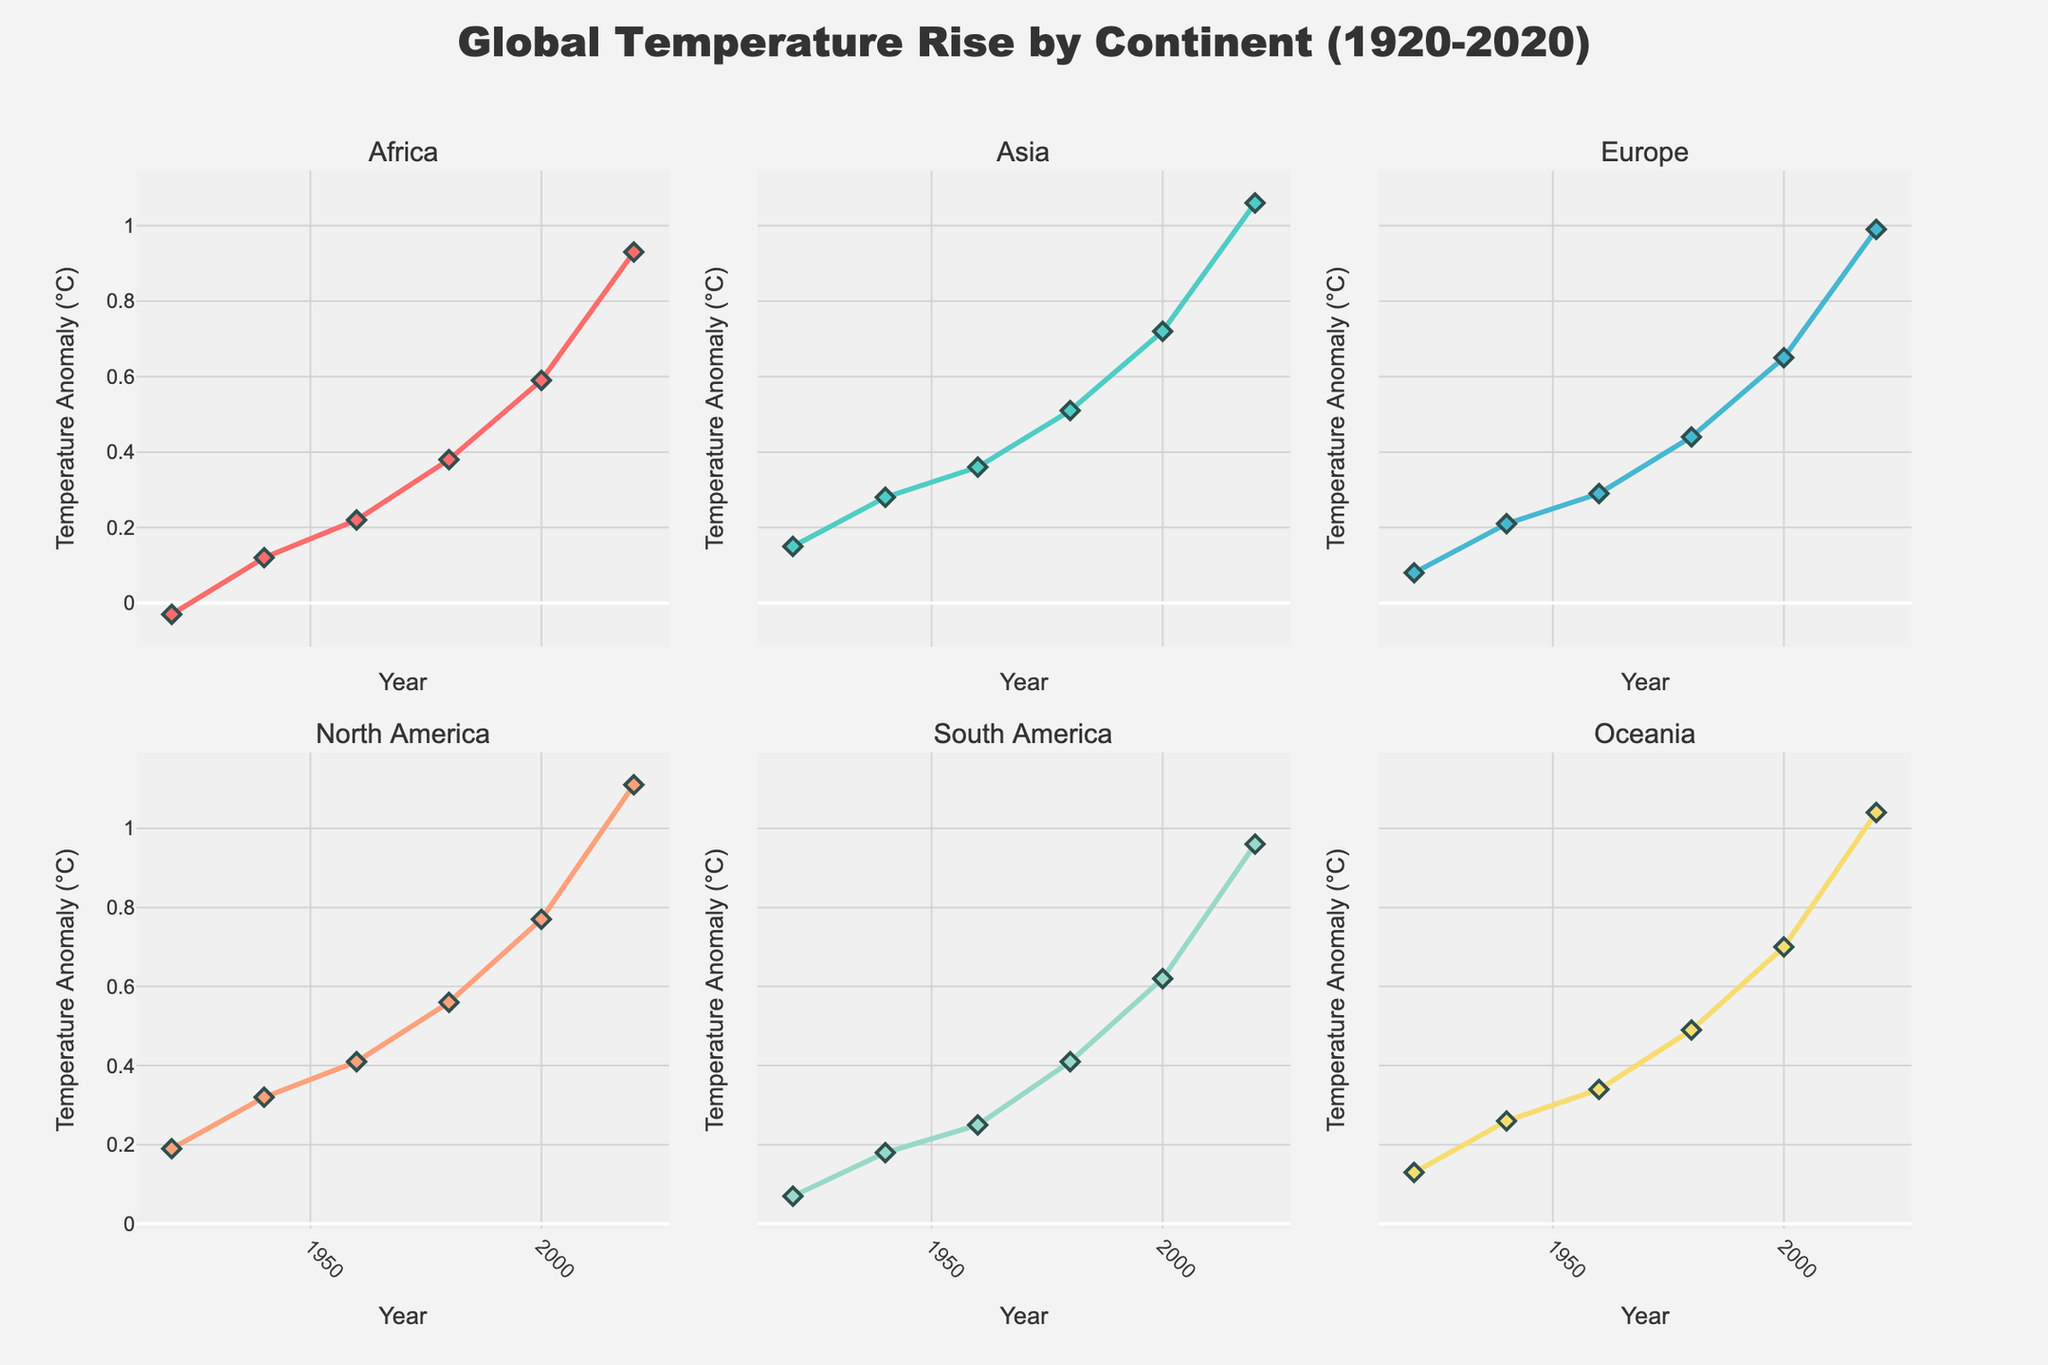What is the title of the figure? The title is centrally positioned at the top of the figure in larger, bold font.
Answer: Global Temperature Rise by Continent (1920-2020) Which continent shows the highest temperature anomaly in 2020? Locate the data point for the year 2020 on all subplots and compare the temperature anomalies.
Answer: North America How does the temperature anomaly in Africa in 1980 compare to that of Oceania in the same year? Check the data points for Africa and Oceania at the year 1980 and compare their values.
Answer: Africa: 0.38°C, Oceania: 0.49°C (Oceania is higher) Which two continents have the closest temperature anomalies in 1940? Check and compare the anomalies in 1940 for all six continents and find the two with the smallest difference.
Answer: Africa and South America What is the overall trend in temperature anomalies from 1920 to 2020 across all continents? Observe the line plots for each continent from 1920 to 2020. All lines show a clear upward trend, indicating rising temperature anomalies over time.
Answer: Increasing trend What's the difference in temperature anomaly between Europe and Asia in the year 2000? Identify the temperature anomaly points for Europe and Asia in the year 2000 and calculate the difference.
Answer: Europe: 0.65°C, Asia: 0.72°C (Difference: 0.07°C) Which continent shows the smallest increase in temperature anomaly from 1980 to 2000? Subtract the 1980 anomaly from the 2000 anomaly for each continent and find the one with the smallest difference.
Answer: Oceania What can be inferred about the global temperature anomaly compared to continent-specific anomalies? Compare the global temperature anomaly line with those of the continents to see higher or lower trends relative to each other.
Answer: Generally lower than most continents, showing a balanced view Which year shows the highest global temperature anomaly within the plotted data? Observe the global temperature anomaly points and identify the highest value.
Answer: 2020 How does South America's temperature anomaly in 1920 compare to North America's in 1940? Check data points for South America in 1920 and North America in 1940 and compare them.
Answer: South America (1920): 0.07°C, North America (1940): 0.32°C (North America is higher) 